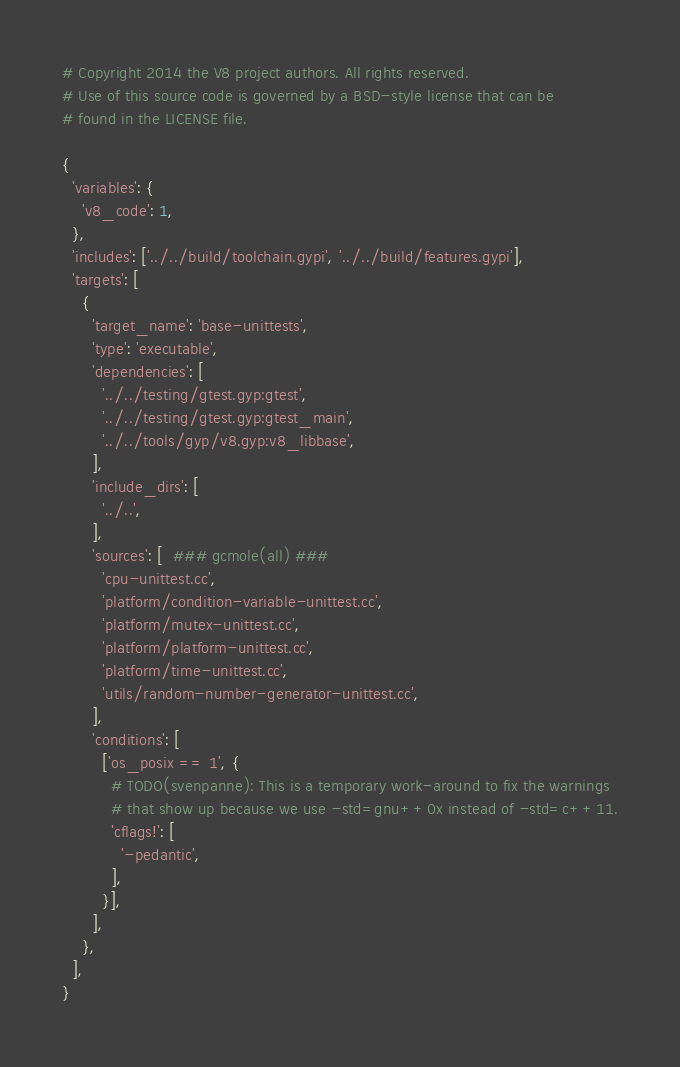Convert code to text. <code><loc_0><loc_0><loc_500><loc_500><_Python_># Copyright 2014 the V8 project authors. All rights reserved.
# Use of this source code is governed by a BSD-style license that can be
# found in the LICENSE file.

{
  'variables': {
    'v8_code': 1,
  },
  'includes': ['../../build/toolchain.gypi', '../../build/features.gypi'],
  'targets': [
    {
      'target_name': 'base-unittests',
      'type': 'executable',
      'dependencies': [
        '../../testing/gtest.gyp:gtest',
        '../../testing/gtest.gyp:gtest_main',
        '../../tools/gyp/v8.gyp:v8_libbase',
      ],
      'include_dirs': [
        '../..',
      ],
      'sources': [  ### gcmole(all) ###
        'cpu-unittest.cc',
        'platform/condition-variable-unittest.cc',
        'platform/mutex-unittest.cc',
        'platform/platform-unittest.cc',
        'platform/time-unittest.cc',
        'utils/random-number-generator-unittest.cc',
      ],
      'conditions': [
        ['os_posix == 1', {
          # TODO(svenpanne): This is a temporary work-around to fix the warnings
          # that show up because we use -std=gnu++0x instead of -std=c++11.
          'cflags!': [
            '-pedantic',
          ],
        }],
      ],
    },
  ],
}
</code> 